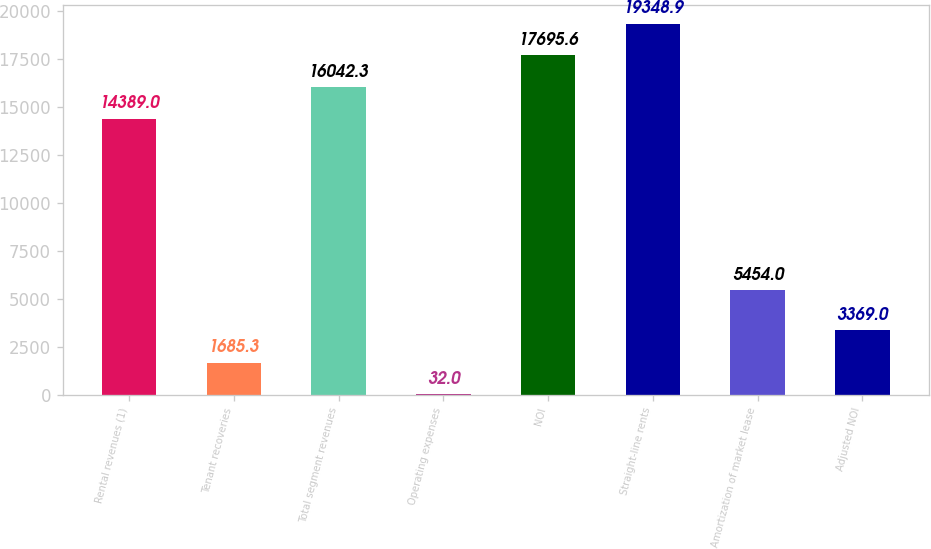<chart> <loc_0><loc_0><loc_500><loc_500><bar_chart><fcel>Rental revenues (1)<fcel>Tenant recoveries<fcel>Total segment revenues<fcel>Operating expenses<fcel>NOI<fcel>Straight-line rents<fcel>Amortization of market lease<fcel>Adjusted NOI<nl><fcel>14389<fcel>1685.3<fcel>16042.3<fcel>32<fcel>17695.6<fcel>19348.9<fcel>5454<fcel>3369<nl></chart> 